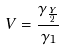Convert formula to latex. <formula><loc_0><loc_0><loc_500><loc_500>V = \frac { \gamma _ { \frac { Y } { 2 } } } { \gamma _ { 1 } }</formula> 